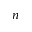Convert formula to latex. <formula><loc_0><loc_0><loc_500><loc_500>n</formula> 